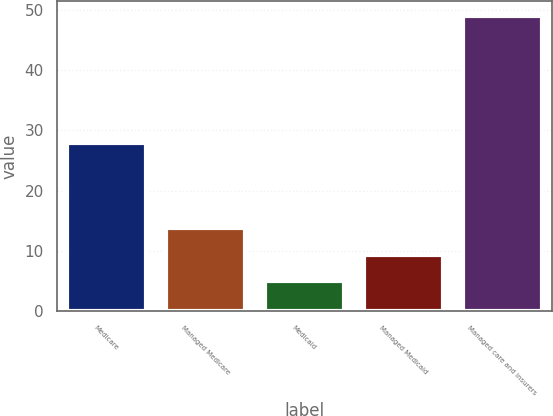Convert chart. <chart><loc_0><loc_0><loc_500><loc_500><bar_chart><fcel>Medicare<fcel>Managed Medicare<fcel>Medicaid<fcel>Managed Medicaid<fcel>Managed care and insurers<nl><fcel>28<fcel>13.8<fcel>5<fcel>9.4<fcel>49<nl></chart> 